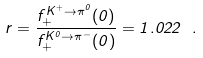<formula> <loc_0><loc_0><loc_500><loc_500>r = \frac { f _ { + } ^ { K ^ { + } \rightarrow \pi ^ { 0 } } ( 0 ) } { f _ { + } ^ { K ^ { 0 } \rightarrow \pi ^ { - } } ( 0 ) } = 1 . 0 2 2 \ .</formula> 